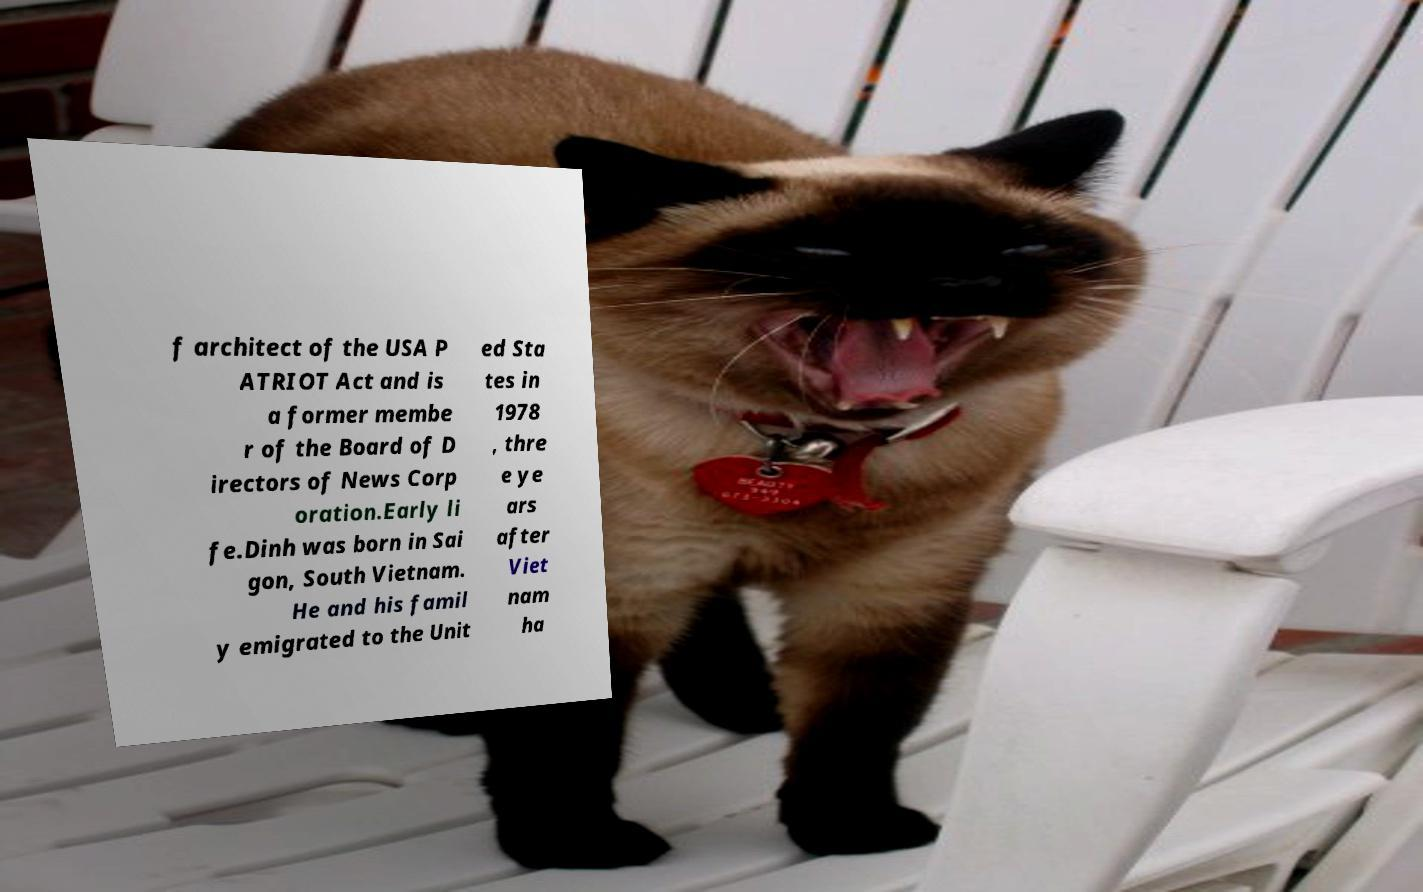Please read and relay the text visible in this image. What does it say? f architect of the USA P ATRIOT Act and is a former membe r of the Board of D irectors of News Corp oration.Early li fe.Dinh was born in Sai gon, South Vietnam. He and his famil y emigrated to the Unit ed Sta tes in 1978 , thre e ye ars after Viet nam ha 